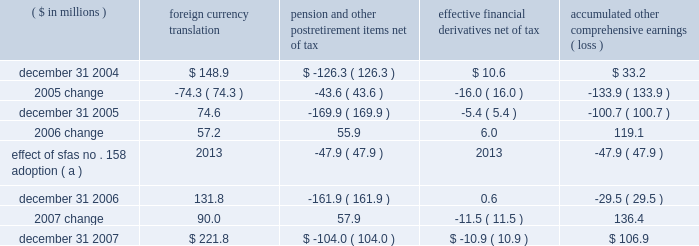Page 71 of 94 notes to consolidated financial statements ball corporation and subsidiaries 16 .
Shareholders 2019 equity ( continued ) on october 24 , 2007 , ball announced the discontinuance of the company 2019s discount on the reinvestment of dividends associated with the company 2019s dividend reinvestment and voluntary stock purchase plan for non- employee shareholders .
The 5 percent discount was discontinued on november 1 , 2007 .
Accumulated other comprehensive earnings ( loss ) the activity related to accumulated other comprehensive earnings ( loss ) was as follows : ( $ in millions ) foreign currency translation pension and postretirement items , net of tax effective financial derivatives , net of tax accumulated comprehensive earnings ( loss ) .
( a ) within the company 2019s 2006 annual report , the consolidated statement of changes in shareholders 2019 equity for the year ended december 31 , 2006 , included a transition adjustment of $ 47.9 million , net of tax , related to the adoption of sfas no .
158 , 201cemployers 2019 accounting for defined benefit pension plans and other postretirement plans , an amendment of fasb statements no .
87 , 88 , 106 and 132 ( r ) , 201d as a component of 2006 comprehensive earnings rather than only as an adjustment to accumulated other comprehensive loss .
The 2006 amounts have been revised to correct the previous reporting .
Notwithstanding the 2005 distribution pursuant to the jobs act , management 2019s intention is to indefinitely reinvest foreign earnings .
Therefore , no taxes have been provided on the foreign currency translation component for any period .
The change in the pension and other postretirement items is presented net of related tax expense of $ 31.3 million and $ 2.9 million for 2007 and 2006 , respectively , and a related tax benefit of $ 27.3 million for 2005 .
The change in the effective financial derivatives is presented net of related tax benefit of $ 3.2 million for 2007 , related tax expense of $ 5.7 million for 2006 and related tax benefit of $ 10.7 million for 2005 .
Stock-based compensation programs effective january 1 , 2006 , ball adopted sfas no .
123 ( revised 2004 ) , 201cshare based payment , 201d which is a revision of sfas no .
123 and supersedes apb opinion no .
25 .
The new standard establishes accounting standards for transactions in which an entity exchanges its equity instruments for goods or services , including stock option and restricted stock grants .
The major differences for ball are that ( 1 ) expense is now recorded in the consolidated statements of earnings for the fair value of new stock option grants and nonvested portions of grants made prior to january 1 , 2006 , and ( 2 ) the company 2019s deposit share program ( discussed below ) is no longer a variable plan that is marked to current market value each month through earnings .
Upon adoption of sfas no .
123 ( revised 2004 ) , ball has chosen to use the modified prospective transition method and the black-scholes valuation model. .
What was the net tax expense in millions for the three year period ended in 2007 relate to the change in the pension and other postretirement items? 
Computations: ((31.3 + 2.9) - 27.3)
Answer: 6.9. Page 71 of 94 notes to consolidated financial statements ball corporation and subsidiaries 16 .
Shareholders 2019 equity ( continued ) on october 24 , 2007 , ball announced the discontinuance of the company 2019s discount on the reinvestment of dividends associated with the company 2019s dividend reinvestment and voluntary stock purchase plan for non- employee shareholders .
The 5 percent discount was discontinued on november 1 , 2007 .
Accumulated other comprehensive earnings ( loss ) the activity related to accumulated other comprehensive earnings ( loss ) was as follows : ( $ in millions ) foreign currency translation pension and postretirement items , net of tax effective financial derivatives , net of tax accumulated comprehensive earnings ( loss ) .
( a ) within the company 2019s 2006 annual report , the consolidated statement of changes in shareholders 2019 equity for the year ended december 31 , 2006 , included a transition adjustment of $ 47.9 million , net of tax , related to the adoption of sfas no .
158 , 201cemployers 2019 accounting for defined benefit pension plans and other postretirement plans , an amendment of fasb statements no .
87 , 88 , 106 and 132 ( r ) , 201d as a component of 2006 comprehensive earnings rather than only as an adjustment to accumulated other comprehensive loss .
The 2006 amounts have been revised to correct the previous reporting .
Notwithstanding the 2005 distribution pursuant to the jobs act , management 2019s intention is to indefinitely reinvest foreign earnings .
Therefore , no taxes have been provided on the foreign currency translation component for any period .
The change in the pension and other postretirement items is presented net of related tax expense of $ 31.3 million and $ 2.9 million for 2007 and 2006 , respectively , and a related tax benefit of $ 27.3 million for 2005 .
The change in the effective financial derivatives is presented net of related tax benefit of $ 3.2 million for 2007 , related tax expense of $ 5.7 million for 2006 and related tax benefit of $ 10.7 million for 2005 .
Stock-based compensation programs effective january 1 , 2006 , ball adopted sfas no .
123 ( revised 2004 ) , 201cshare based payment , 201d which is a revision of sfas no .
123 and supersedes apb opinion no .
25 .
The new standard establishes accounting standards for transactions in which an entity exchanges its equity instruments for goods or services , including stock option and restricted stock grants .
The major differences for ball are that ( 1 ) expense is now recorded in the consolidated statements of earnings for the fair value of new stock option grants and nonvested portions of grants made prior to january 1 , 2006 , and ( 2 ) the company 2019s deposit share program ( discussed below ) is no longer a variable plan that is marked to current market value each month through earnings .
Upon adoption of sfas no .
123 ( revised 2004 ) , ball has chosen to use the modified prospective transition method and the black-scholes valuation model. .
What was the net tax expense for the 3 years ended 2005 related to the change in financial derivatives ( in millions? )? 
Computations: ((5.7 - 3.2) - 10.7)
Answer: -8.2. 